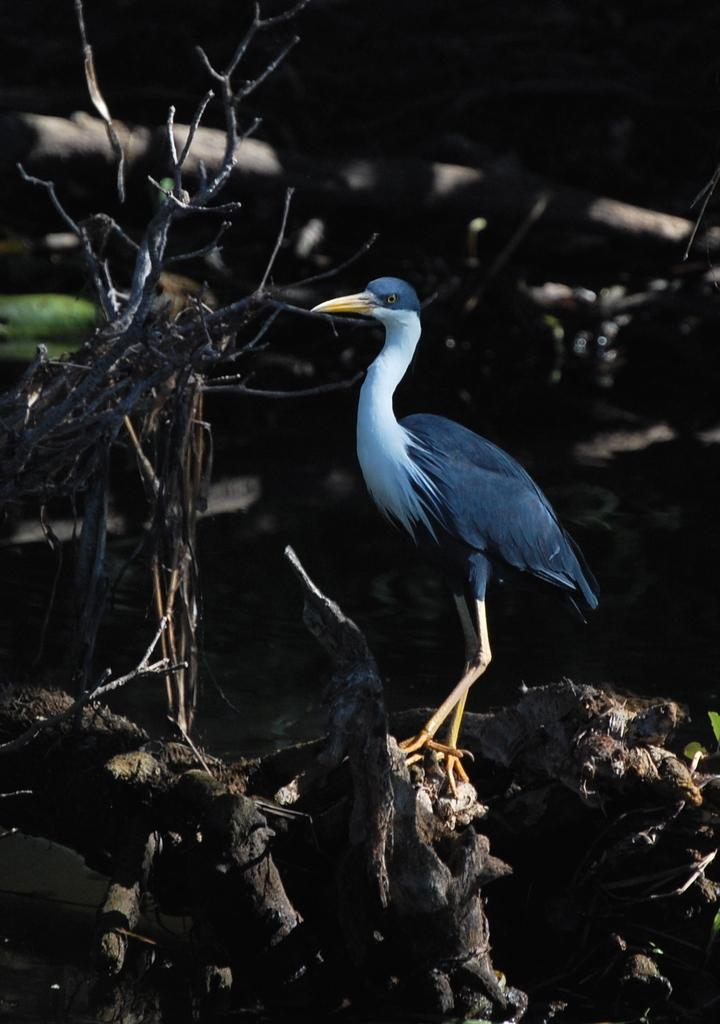What type of animal can be seen in the image? There is a bird in the image. What is the bird sitting on? The bird is sitting on wood. What type of hospital equipment can be seen in the image? There is no hospital equipment present in the image; it features a bird sitting on wood. What type of doll is sitting next to the bird in the image? There is no doll present in the image; it only features a bird sitting on wood. 